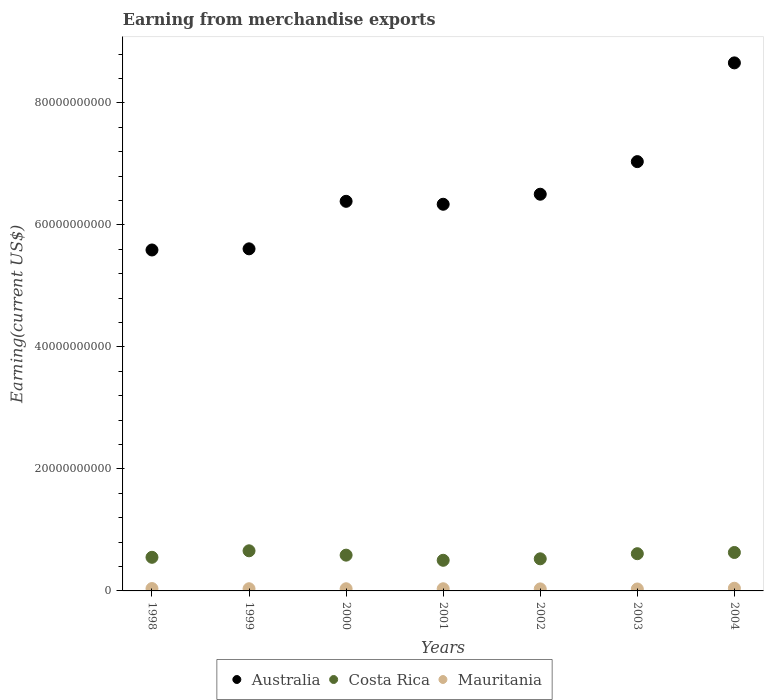How many different coloured dotlines are there?
Provide a succinct answer. 3. Is the number of dotlines equal to the number of legend labels?
Offer a terse response. Yes. What is the amount earned from merchandise exports in Mauritania in 1998?
Your response must be concise. 3.87e+08. Across all years, what is the maximum amount earned from merchandise exports in Australia?
Your answer should be very brief. 8.66e+1. Across all years, what is the minimum amount earned from merchandise exports in Mauritania?
Offer a very short reply. 3.18e+08. In which year was the amount earned from merchandise exports in Costa Rica maximum?
Keep it short and to the point. 1999. In which year was the amount earned from merchandise exports in Australia minimum?
Provide a short and direct response. 1998. What is the total amount earned from merchandise exports in Mauritania in the graph?
Offer a very short reply. 2.54e+09. What is the difference between the amount earned from merchandise exports in Costa Rica in 2000 and that in 2001?
Offer a very short reply. 8.44e+08. What is the difference between the amount earned from merchandise exports in Mauritania in 2002 and the amount earned from merchandise exports in Costa Rica in 1999?
Offer a very short reply. -6.25e+09. What is the average amount earned from merchandise exports in Costa Rica per year?
Your response must be concise. 5.81e+09. In the year 1998, what is the difference between the amount earned from merchandise exports in Australia and amount earned from merchandise exports in Costa Rica?
Give a very brief answer. 5.04e+1. What is the ratio of the amount earned from merchandise exports in Australia in 1998 to that in 2003?
Your response must be concise. 0.79. What is the difference between the highest and the second highest amount earned from merchandise exports in Australia?
Offer a terse response. 1.62e+1. What is the difference between the highest and the lowest amount earned from merchandise exports in Australia?
Your answer should be compact. 3.07e+1. In how many years, is the amount earned from merchandise exports in Mauritania greater than the average amount earned from merchandise exports in Mauritania taken over all years?
Provide a succinct answer. 2. Is it the case that in every year, the sum of the amount earned from merchandise exports in Australia and amount earned from merchandise exports in Mauritania  is greater than the amount earned from merchandise exports in Costa Rica?
Your answer should be compact. Yes. Does the amount earned from merchandise exports in Australia monotonically increase over the years?
Your answer should be very brief. No. Does the graph contain grids?
Keep it short and to the point. No. Where does the legend appear in the graph?
Your answer should be very brief. Bottom center. How many legend labels are there?
Keep it short and to the point. 3. What is the title of the graph?
Your answer should be compact. Earning from merchandise exports. Does "Antigua and Barbuda" appear as one of the legend labels in the graph?
Your answer should be very brief. No. What is the label or title of the X-axis?
Keep it short and to the point. Years. What is the label or title of the Y-axis?
Keep it short and to the point. Earning(current US$). What is the Earning(current US$) of Australia in 1998?
Offer a very short reply. 5.59e+1. What is the Earning(current US$) in Costa Rica in 1998?
Your answer should be very brief. 5.51e+09. What is the Earning(current US$) of Mauritania in 1998?
Your answer should be compact. 3.87e+08. What is the Earning(current US$) of Australia in 1999?
Provide a short and direct response. 5.61e+1. What is the Earning(current US$) of Costa Rica in 1999?
Give a very brief answer. 6.58e+09. What is the Earning(current US$) in Mauritania in 1999?
Make the answer very short. 3.58e+08. What is the Earning(current US$) of Australia in 2000?
Offer a terse response. 6.39e+1. What is the Earning(current US$) in Costa Rica in 2000?
Offer a terse response. 5.86e+09. What is the Earning(current US$) in Mauritania in 2000?
Give a very brief answer. 3.55e+08. What is the Earning(current US$) of Australia in 2001?
Make the answer very short. 6.34e+1. What is the Earning(current US$) in Costa Rica in 2001?
Your response must be concise. 5.02e+09. What is the Earning(current US$) in Mauritania in 2001?
Provide a short and direct response. 3.55e+08. What is the Earning(current US$) of Australia in 2002?
Your answer should be compact. 6.50e+1. What is the Earning(current US$) in Costa Rica in 2002?
Your answer should be compact. 5.26e+09. What is the Earning(current US$) of Mauritania in 2002?
Your answer should be compact. 3.32e+08. What is the Earning(current US$) in Australia in 2003?
Your answer should be very brief. 7.04e+1. What is the Earning(current US$) in Costa Rica in 2003?
Make the answer very short. 6.10e+09. What is the Earning(current US$) in Mauritania in 2003?
Ensure brevity in your answer.  3.18e+08. What is the Earning(current US$) in Australia in 2004?
Make the answer very short. 8.66e+1. What is the Earning(current US$) in Costa Rica in 2004?
Provide a short and direct response. 6.30e+09. What is the Earning(current US$) of Mauritania in 2004?
Make the answer very short. 4.40e+08. Across all years, what is the maximum Earning(current US$) in Australia?
Make the answer very short. 8.66e+1. Across all years, what is the maximum Earning(current US$) in Costa Rica?
Ensure brevity in your answer.  6.58e+09. Across all years, what is the maximum Earning(current US$) in Mauritania?
Give a very brief answer. 4.40e+08. Across all years, what is the minimum Earning(current US$) in Australia?
Keep it short and to the point. 5.59e+1. Across all years, what is the minimum Earning(current US$) of Costa Rica?
Your response must be concise. 5.02e+09. Across all years, what is the minimum Earning(current US$) of Mauritania?
Provide a short and direct response. 3.18e+08. What is the total Earning(current US$) in Australia in the graph?
Your answer should be very brief. 4.61e+11. What is the total Earning(current US$) of Costa Rica in the graph?
Your response must be concise. 4.06e+1. What is the total Earning(current US$) of Mauritania in the graph?
Give a very brief answer. 2.54e+09. What is the difference between the Earning(current US$) of Australia in 1998 and that in 1999?
Ensure brevity in your answer.  -1.87e+08. What is the difference between the Earning(current US$) in Costa Rica in 1998 and that in 1999?
Provide a succinct answer. -1.07e+09. What is the difference between the Earning(current US$) in Mauritania in 1998 and that in 1999?
Make the answer very short. 2.89e+07. What is the difference between the Earning(current US$) in Australia in 1998 and that in 2000?
Keep it short and to the point. -7.98e+09. What is the difference between the Earning(current US$) of Costa Rica in 1998 and that in 2000?
Ensure brevity in your answer.  -3.54e+08. What is the difference between the Earning(current US$) of Mauritania in 1998 and that in 2000?
Keep it short and to the point. 3.22e+07. What is the difference between the Earning(current US$) of Australia in 1998 and that in 2001?
Keep it short and to the point. -7.49e+09. What is the difference between the Earning(current US$) of Costa Rica in 1998 and that in 2001?
Ensure brevity in your answer.  4.90e+08. What is the difference between the Earning(current US$) of Mauritania in 1998 and that in 2001?
Ensure brevity in your answer.  3.15e+07. What is the difference between the Earning(current US$) in Australia in 1998 and that in 2002?
Ensure brevity in your answer.  -9.14e+09. What is the difference between the Earning(current US$) of Costa Rica in 1998 and that in 2002?
Your answer should be compact. 2.47e+08. What is the difference between the Earning(current US$) in Mauritania in 1998 and that in 2002?
Provide a short and direct response. 5.51e+07. What is the difference between the Earning(current US$) of Australia in 1998 and that in 2003?
Ensure brevity in your answer.  -1.45e+1. What is the difference between the Earning(current US$) in Costa Rica in 1998 and that in 2003?
Your answer should be compact. -5.91e+08. What is the difference between the Earning(current US$) of Mauritania in 1998 and that in 2003?
Provide a succinct answer. 6.84e+07. What is the difference between the Earning(current US$) in Australia in 1998 and that in 2004?
Make the answer very short. -3.07e+1. What is the difference between the Earning(current US$) of Costa Rica in 1998 and that in 2004?
Your answer should be very brief. -7.90e+08. What is the difference between the Earning(current US$) of Mauritania in 1998 and that in 2004?
Ensure brevity in your answer.  -5.29e+07. What is the difference between the Earning(current US$) of Australia in 1999 and that in 2000?
Make the answer very short. -7.79e+09. What is the difference between the Earning(current US$) of Costa Rica in 1999 and that in 2000?
Provide a succinct answer. 7.12e+08. What is the difference between the Earning(current US$) in Mauritania in 1999 and that in 2000?
Your answer should be very brief. 3.26e+06. What is the difference between the Earning(current US$) in Australia in 1999 and that in 2001?
Make the answer very short. -7.31e+09. What is the difference between the Earning(current US$) in Costa Rica in 1999 and that in 2001?
Your response must be concise. 1.56e+09. What is the difference between the Earning(current US$) of Mauritania in 1999 and that in 2001?
Provide a short and direct response. 2.58e+06. What is the difference between the Earning(current US$) in Australia in 1999 and that in 2002?
Provide a short and direct response. -8.95e+09. What is the difference between the Earning(current US$) of Costa Rica in 1999 and that in 2002?
Your answer should be compact. 1.31e+09. What is the difference between the Earning(current US$) of Mauritania in 1999 and that in 2002?
Your answer should be very brief. 2.62e+07. What is the difference between the Earning(current US$) in Australia in 1999 and that in 2003?
Offer a very short reply. -1.43e+1. What is the difference between the Earning(current US$) in Costa Rica in 1999 and that in 2003?
Offer a very short reply. 4.75e+08. What is the difference between the Earning(current US$) in Mauritania in 1999 and that in 2003?
Your answer should be very brief. 3.95e+07. What is the difference between the Earning(current US$) in Australia in 1999 and that in 2004?
Give a very brief answer. -3.05e+1. What is the difference between the Earning(current US$) in Costa Rica in 1999 and that in 2004?
Offer a very short reply. 2.76e+08. What is the difference between the Earning(current US$) in Mauritania in 1999 and that in 2004?
Provide a short and direct response. -8.18e+07. What is the difference between the Earning(current US$) of Australia in 2000 and that in 2001?
Your response must be concise. 4.83e+08. What is the difference between the Earning(current US$) in Costa Rica in 2000 and that in 2001?
Offer a terse response. 8.44e+08. What is the difference between the Earning(current US$) in Mauritania in 2000 and that in 2001?
Keep it short and to the point. -6.79e+05. What is the difference between the Earning(current US$) in Australia in 2000 and that in 2002?
Provide a short and direct response. -1.16e+09. What is the difference between the Earning(current US$) in Costa Rica in 2000 and that in 2002?
Make the answer very short. 6.01e+08. What is the difference between the Earning(current US$) in Mauritania in 2000 and that in 2002?
Keep it short and to the point. 2.29e+07. What is the difference between the Earning(current US$) of Australia in 2000 and that in 2003?
Your response must be concise. -6.51e+09. What is the difference between the Earning(current US$) in Costa Rica in 2000 and that in 2003?
Offer a terse response. -2.37e+08. What is the difference between the Earning(current US$) in Mauritania in 2000 and that in 2003?
Your answer should be compact. 3.62e+07. What is the difference between the Earning(current US$) in Australia in 2000 and that in 2004?
Make the answer very short. -2.27e+1. What is the difference between the Earning(current US$) in Costa Rica in 2000 and that in 2004?
Provide a succinct answer. -4.36e+08. What is the difference between the Earning(current US$) of Mauritania in 2000 and that in 2004?
Give a very brief answer. -8.50e+07. What is the difference between the Earning(current US$) of Australia in 2001 and that in 2002?
Make the answer very short. -1.65e+09. What is the difference between the Earning(current US$) in Costa Rica in 2001 and that in 2002?
Your answer should be very brief. -2.43e+08. What is the difference between the Earning(current US$) of Mauritania in 2001 and that in 2002?
Your answer should be very brief. 2.36e+07. What is the difference between the Earning(current US$) of Australia in 2001 and that in 2003?
Keep it short and to the point. -6.99e+09. What is the difference between the Earning(current US$) of Costa Rica in 2001 and that in 2003?
Offer a very short reply. -1.08e+09. What is the difference between the Earning(current US$) of Mauritania in 2001 and that in 2003?
Provide a short and direct response. 3.69e+07. What is the difference between the Earning(current US$) in Australia in 2001 and that in 2004?
Your response must be concise. -2.32e+1. What is the difference between the Earning(current US$) of Costa Rica in 2001 and that in 2004?
Offer a very short reply. -1.28e+09. What is the difference between the Earning(current US$) of Mauritania in 2001 and that in 2004?
Offer a very short reply. -8.44e+07. What is the difference between the Earning(current US$) of Australia in 2002 and that in 2003?
Offer a very short reply. -5.34e+09. What is the difference between the Earning(current US$) of Costa Rica in 2002 and that in 2003?
Make the answer very short. -8.38e+08. What is the difference between the Earning(current US$) in Mauritania in 2002 and that in 2003?
Ensure brevity in your answer.  1.33e+07. What is the difference between the Earning(current US$) of Australia in 2002 and that in 2004?
Offer a very short reply. -2.15e+1. What is the difference between the Earning(current US$) of Costa Rica in 2002 and that in 2004?
Provide a succinct answer. -1.04e+09. What is the difference between the Earning(current US$) of Mauritania in 2002 and that in 2004?
Provide a succinct answer. -1.08e+08. What is the difference between the Earning(current US$) in Australia in 2003 and that in 2004?
Keep it short and to the point. -1.62e+1. What is the difference between the Earning(current US$) of Costa Rica in 2003 and that in 2004?
Make the answer very short. -1.99e+08. What is the difference between the Earning(current US$) of Mauritania in 2003 and that in 2004?
Your answer should be compact. -1.21e+08. What is the difference between the Earning(current US$) of Australia in 1998 and the Earning(current US$) of Costa Rica in 1999?
Offer a terse response. 4.93e+1. What is the difference between the Earning(current US$) in Australia in 1998 and the Earning(current US$) in Mauritania in 1999?
Provide a succinct answer. 5.55e+1. What is the difference between the Earning(current US$) in Costa Rica in 1998 and the Earning(current US$) in Mauritania in 1999?
Provide a succinct answer. 5.15e+09. What is the difference between the Earning(current US$) of Australia in 1998 and the Earning(current US$) of Costa Rica in 2000?
Your answer should be very brief. 5.00e+1. What is the difference between the Earning(current US$) of Australia in 1998 and the Earning(current US$) of Mauritania in 2000?
Provide a short and direct response. 5.55e+1. What is the difference between the Earning(current US$) in Costa Rica in 1998 and the Earning(current US$) in Mauritania in 2000?
Give a very brief answer. 5.16e+09. What is the difference between the Earning(current US$) in Australia in 1998 and the Earning(current US$) in Costa Rica in 2001?
Make the answer very short. 5.09e+1. What is the difference between the Earning(current US$) of Australia in 1998 and the Earning(current US$) of Mauritania in 2001?
Make the answer very short. 5.55e+1. What is the difference between the Earning(current US$) of Costa Rica in 1998 and the Earning(current US$) of Mauritania in 2001?
Offer a terse response. 5.16e+09. What is the difference between the Earning(current US$) of Australia in 1998 and the Earning(current US$) of Costa Rica in 2002?
Give a very brief answer. 5.06e+1. What is the difference between the Earning(current US$) in Australia in 1998 and the Earning(current US$) in Mauritania in 2002?
Provide a short and direct response. 5.56e+1. What is the difference between the Earning(current US$) in Costa Rica in 1998 and the Earning(current US$) in Mauritania in 2002?
Ensure brevity in your answer.  5.18e+09. What is the difference between the Earning(current US$) in Australia in 1998 and the Earning(current US$) in Costa Rica in 2003?
Your response must be concise. 4.98e+1. What is the difference between the Earning(current US$) of Australia in 1998 and the Earning(current US$) of Mauritania in 2003?
Your answer should be very brief. 5.56e+1. What is the difference between the Earning(current US$) in Costa Rica in 1998 and the Earning(current US$) in Mauritania in 2003?
Ensure brevity in your answer.  5.19e+09. What is the difference between the Earning(current US$) of Australia in 1998 and the Earning(current US$) of Costa Rica in 2004?
Your answer should be compact. 4.96e+1. What is the difference between the Earning(current US$) in Australia in 1998 and the Earning(current US$) in Mauritania in 2004?
Your answer should be very brief. 5.55e+1. What is the difference between the Earning(current US$) of Costa Rica in 1998 and the Earning(current US$) of Mauritania in 2004?
Offer a terse response. 5.07e+09. What is the difference between the Earning(current US$) of Australia in 1999 and the Earning(current US$) of Costa Rica in 2000?
Keep it short and to the point. 5.02e+1. What is the difference between the Earning(current US$) of Australia in 1999 and the Earning(current US$) of Mauritania in 2000?
Provide a succinct answer. 5.57e+1. What is the difference between the Earning(current US$) in Costa Rica in 1999 and the Earning(current US$) in Mauritania in 2000?
Your answer should be very brief. 6.22e+09. What is the difference between the Earning(current US$) in Australia in 1999 and the Earning(current US$) in Costa Rica in 2001?
Your answer should be compact. 5.11e+1. What is the difference between the Earning(current US$) in Australia in 1999 and the Earning(current US$) in Mauritania in 2001?
Keep it short and to the point. 5.57e+1. What is the difference between the Earning(current US$) of Costa Rica in 1999 and the Earning(current US$) of Mauritania in 2001?
Provide a short and direct response. 6.22e+09. What is the difference between the Earning(current US$) of Australia in 1999 and the Earning(current US$) of Costa Rica in 2002?
Offer a terse response. 5.08e+1. What is the difference between the Earning(current US$) of Australia in 1999 and the Earning(current US$) of Mauritania in 2002?
Give a very brief answer. 5.57e+1. What is the difference between the Earning(current US$) of Costa Rica in 1999 and the Earning(current US$) of Mauritania in 2002?
Keep it short and to the point. 6.25e+09. What is the difference between the Earning(current US$) of Australia in 1999 and the Earning(current US$) of Costa Rica in 2003?
Your response must be concise. 5.00e+1. What is the difference between the Earning(current US$) in Australia in 1999 and the Earning(current US$) in Mauritania in 2003?
Your response must be concise. 5.58e+1. What is the difference between the Earning(current US$) in Costa Rica in 1999 and the Earning(current US$) in Mauritania in 2003?
Offer a terse response. 6.26e+09. What is the difference between the Earning(current US$) of Australia in 1999 and the Earning(current US$) of Costa Rica in 2004?
Provide a short and direct response. 4.98e+1. What is the difference between the Earning(current US$) of Australia in 1999 and the Earning(current US$) of Mauritania in 2004?
Offer a very short reply. 5.56e+1. What is the difference between the Earning(current US$) of Costa Rica in 1999 and the Earning(current US$) of Mauritania in 2004?
Provide a succinct answer. 6.14e+09. What is the difference between the Earning(current US$) of Australia in 2000 and the Earning(current US$) of Costa Rica in 2001?
Offer a very short reply. 5.88e+1. What is the difference between the Earning(current US$) in Australia in 2000 and the Earning(current US$) in Mauritania in 2001?
Keep it short and to the point. 6.35e+1. What is the difference between the Earning(current US$) in Costa Rica in 2000 and the Earning(current US$) in Mauritania in 2001?
Your response must be concise. 5.51e+09. What is the difference between the Earning(current US$) of Australia in 2000 and the Earning(current US$) of Costa Rica in 2002?
Your answer should be compact. 5.86e+1. What is the difference between the Earning(current US$) in Australia in 2000 and the Earning(current US$) in Mauritania in 2002?
Give a very brief answer. 6.35e+1. What is the difference between the Earning(current US$) in Costa Rica in 2000 and the Earning(current US$) in Mauritania in 2002?
Provide a succinct answer. 5.53e+09. What is the difference between the Earning(current US$) of Australia in 2000 and the Earning(current US$) of Costa Rica in 2003?
Your answer should be very brief. 5.78e+1. What is the difference between the Earning(current US$) of Australia in 2000 and the Earning(current US$) of Mauritania in 2003?
Make the answer very short. 6.36e+1. What is the difference between the Earning(current US$) of Costa Rica in 2000 and the Earning(current US$) of Mauritania in 2003?
Your answer should be compact. 5.55e+09. What is the difference between the Earning(current US$) of Australia in 2000 and the Earning(current US$) of Costa Rica in 2004?
Your answer should be compact. 5.76e+1. What is the difference between the Earning(current US$) in Australia in 2000 and the Earning(current US$) in Mauritania in 2004?
Keep it short and to the point. 6.34e+1. What is the difference between the Earning(current US$) in Costa Rica in 2000 and the Earning(current US$) in Mauritania in 2004?
Ensure brevity in your answer.  5.43e+09. What is the difference between the Earning(current US$) of Australia in 2001 and the Earning(current US$) of Costa Rica in 2002?
Offer a very short reply. 5.81e+1. What is the difference between the Earning(current US$) of Australia in 2001 and the Earning(current US$) of Mauritania in 2002?
Your response must be concise. 6.31e+1. What is the difference between the Earning(current US$) in Costa Rica in 2001 and the Earning(current US$) in Mauritania in 2002?
Your answer should be compact. 4.69e+09. What is the difference between the Earning(current US$) in Australia in 2001 and the Earning(current US$) in Costa Rica in 2003?
Offer a very short reply. 5.73e+1. What is the difference between the Earning(current US$) of Australia in 2001 and the Earning(current US$) of Mauritania in 2003?
Ensure brevity in your answer.  6.31e+1. What is the difference between the Earning(current US$) of Costa Rica in 2001 and the Earning(current US$) of Mauritania in 2003?
Offer a very short reply. 4.70e+09. What is the difference between the Earning(current US$) in Australia in 2001 and the Earning(current US$) in Costa Rica in 2004?
Your response must be concise. 5.71e+1. What is the difference between the Earning(current US$) of Australia in 2001 and the Earning(current US$) of Mauritania in 2004?
Keep it short and to the point. 6.29e+1. What is the difference between the Earning(current US$) of Costa Rica in 2001 and the Earning(current US$) of Mauritania in 2004?
Provide a succinct answer. 4.58e+09. What is the difference between the Earning(current US$) of Australia in 2002 and the Earning(current US$) of Costa Rica in 2003?
Your response must be concise. 5.89e+1. What is the difference between the Earning(current US$) of Australia in 2002 and the Earning(current US$) of Mauritania in 2003?
Your response must be concise. 6.47e+1. What is the difference between the Earning(current US$) of Costa Rica in 2002 and the Earning(current US$) of Mauritania in 2003?
Your answer should be very brief. 4.95e+09. What is the difference between the Earning(current US$) in Australia in 2002 and the Earning(current US$) in Costa Rica in 2004?
Your answer should be very brief. 5.87e+1. What is the difference between the Earning(current US$) of Australia in 2002 and the Earning(current US$) of Mauritania in 2004?
Give a very brief answer. 6.46e+1. What is the difference between the Earning(current US$) in Costa Rica in 2002 and the Earning(current US$) in Mauritania in 2004?
Your answer should be very brief. 4.82e+09. What is the difference between the Earning(current US$) in Australia in 2003 and the Earning(current US$) in Costa Rica in 2004?
Make the answer very short. 6.41e+1. What is the difference between the Earning(current US$) of Australia in 2003 and the Earning(current US$) of Mauritania in 2004?
Provide a short and direct response. 6.99e+1. What is the difference between the Earning(current US$) of Costa Rica in 2003 and the Earning(current US$) of Mauritania in 2004?
Your answer should be very brief. 5.66e+09. What is the average Earning(current US$) in Australia per year?
Offer a very short reply. 6.59e+1. What is the average Earning(current US$) of Costa Rica per year?
Provide a short and direct response. 5.81e+09. What is the average Earning(current US$) of Mauritania per year?
Your answer should be very brief. 3.63e+08. In the year 1998, what is the difference between the Earning(current US$) in Australia and Earning(current US$) in Costa Rica?
Keep it short and to the point. 5.04e+1. In the year 1998, what is the difference between the Earning(current US$) of Australia and Earning(current US$) of Mauritania?
Provide a short and direct response. 5.55e+1. In the year 1998, what is the difference between the Earning(current US$) of Costa Rica and Earning(current US$) of Mauritania?
Provide a short and direct response. 5.12e+09. In the year 1999, what is the difference between the Earning(current US$) in Australia and Earning(current US$) in Costa Rica?
Offer a terse response. 4.95e+1. In the year 1999, what is the difference between the Earning(current US$) in Australia and Earning(current US$) in Mauritania?
Your answer should be compact. 5.57e+1. In the year 1999, what is the difference between the Earning(current US$) of Costa Rica and Earning(current US$) of Mauritania?
Your answer should be very brief. 6.22e+09. In the year 2000, what is the difference between the Earning(current US$) in Australia and Earning(current US$) in Costa Rica?
Ensure brevity in your answer.  5.80e+1. In the year 2000, what is the difference between the Earning(current US$) of Australia and Earning(current US$) of Mauritania?
Keep it short and to the point. 6.35e+1. In the year 2000, what is the difference between the Earning(current US$) in Costa Rica and Earning(current US$) in Mauritania?
Your response must be concise. 5.51e+09. In the year 2001, what is the difference between the Earning(current US$) in Australia and Earning(current US$) in Costa Rica?
Your response must be concise. 5.84e+1. In the year 2001, what is the difference between the Earning(current US$) in Australia and Earning(current US$) in Mauritania?
Make the answer very short. 6.30e+1. In the year 2001, what is the difference between the Earning(current US$) in Costa Rica and Earning(current US$) in Mauritania?
Ensure brevity in your answer.  4.67e+09. In the year 2002, what is the difference between the Earning(current US$) in Australia and Earning(current US$) in Costa Rica?
Your answer should be very brief. 5.98e+1. In the year 2002, what is the difference between the Earning(current US$) of Australia and Earning(current US$) of Mauritania?
Offer a very short reply. 6.47e+1. In the year 2002, what is the difference between the Earning(current US$) of Costa Rica and Earning(current US$) of Mauritania?
Your answer should be very brief. 4.93e+09. In the year 2003, what is the difference between the Earning(current US$) in Australia and Earning(current US$) in Costa Rica?
Your response must be concise. 6.43e+1. In the year 2003, what is the difference between the Earning(current US$) of Australia and Earning(current US$) of Mauritania?
Your answer should be very brief. 7.01e+1. In the year 2003, what is the difference between the Earning(current US$) in Costa Rica and Earning(current US$) in Mauritania?
Provide a succinct answer. 5.78e+09. In the year 2004, what is the difference between the Earning(current US$) in Australia and Earning(current US$) in Costa Rica?
Your answer should be compact. 8.03e+1. In the year 2004, what is the difference between the Earning(current US$) of Australia and Earning(current US$) of Mauritania?
Your answer should be very brief. 8.61e+1. In the year 2004, what is the difference between the Earning(current US$) in Costa Rica and Earning(current US$) in Mauritania?
Your answer should be compact. 5.86e+09. What is the ratio of the Earning(current US$) in Costa Rica in 1998 to that in 1999?
Give a very brief answer. 0.84. What is the ratio of the Earning(current US$) in Mauritania in 1998 to that in 1999?
Provide a short and direct response. 1.08. What is the ratio of the Earning(current US$) in Australia in 1998 to that in 2000?
Offer a terse response. 0.88. What is the ratio of the Earning(current US$) in Costa Rica in 1998 to that in 2000?
Your response must be concise. 0.94. What is the ratio of the Earning(current US$) in Mauritania in 1998 to that in 2000?
Provide a succinct answer. 1.09. What is the ratio of the Earning(current US$) in Australia in 1998 to that in 2001?
Your answer should be very brief. 0.88. What is the ratio of the Earning(current US$) in Costa Rica in 1998 to that in 2001?
Your answer should be compact. 1.1. What is the ratio of the Earning(current US$) in Mauritania in 1998 to that in 2001?
Keep it short and to the point. 1.09. What is the ratio of the Earning(current US$) of Australia in 1998 to that in 2002?
Provide a short and direct response. 0.86. What is the ratio of the Earning(current US$) in Costa Rica in 1998 to that in 2002?
Keep it short and to the point. 1.05. What is the ratio of the Earning(current US$) of Mauritania in 1998 to that in 2002?
Ensure brevity in your answer.  1.17. What is the ratio of the Earning(current US$) in Australia in 1998 to that in 2003?
Make the answer very short. 0.79. What is the ratio of the Earning(current US$) in Costa Rica in 1998 to that in 2003?
Ensure brevity in your answer.  0.9. What is the ratio of the Earning(current US$) in Mauritania in 1998 to that in 2003?
Give a very brief answer. 1.21. What is the ratio of the Earning(current US$) in Australia in 1998 to that in 2004?
Offer a terse response. 0.65. What is the ratio of the Earning(current US$) in Costa Rica in 1998 to that in 2004?
Your answer should be very brief. 0.87. What is the ratio of the Earning(current US$) of Mauritania in 1998 to that in 2004?
Ensure brevity in your answer.  0.88. What is the ratio of the Earning(current US$) in Australia in 1999 to that in 2000?
Keep it short and to the point. 0.88. What is the ratio of the Earning(current US$) of Costa Rica in 1999 to that in 2000?
Keep it short and to the point. 1.12. What is the ratio of the Earning(current US$) of Mauritania in 1999 to that in 2000?
Provide a short and direct response. 1.01. What is the ratio of the Earning(current US$) of Australia in 1999 to that in 2001?
Provide a succinct answer. 0.88. What is the ratio of the Earning(current US$) in Costa Rica in 1999 to that in 2001?
Ensure brevity in your answer.  1.31. What is the ratio of the Earning(current US$) in Mauritania in 1999 to that in 2001?
Offer a very short reply. 1.01. What is the ratio of the Earning(current US$) in Australia in 1999 to that in 2002?
Your answer should be compact. 0.86. What is the ratio of the Earning(current US$) of Costa Rica in 1999 to that in 2002?
Provide a short and direct response. 1.25. What is the ratio of the Earning(current US$) in Mauritania in 1999 to that in 2002?
Provide a succinct answer. 1.08. What is the ratio of the Earning(current US$) of Australia in 1999 to that in 2003?
Ensure brevity in your answer.  0.8. What is the ratio of the Earning(current US$) in Costa Rica in 1999 to that in 2003?
Your response must be concise. 1.08. What is the ratio of the Earning(current US$) in Mauritania in 1999 to that in 2003?
Keep it short and to the point. 1.12. What is the ratio of the Earning(current US$) in Australia in 1999 to that in 2004?
Provide a succinct answer. 0.65. What is the ratio of the Earning(current US$) in Costa Rica in 1999 to that in 2004?
Your response must be concise. 1.04. What is the ratio of the Earning(current US$) in Mauritania in 1999 to that in 2004?
Offer a terse response. 0.81. What is the ratio of the Earning(current US$) of Australia in 2000 to that in 2001?
Your response must be concise. 1.01. What is the ratio of the Earning(current US$) of Costa Rica in 2000 to that in 2001?
Your answer should be compact. 1.17. What is the ratio of the Earning(current US$) in Mauritania in 2000 to that in 2001?
Give a very brief answer. 1. What is the ratio of the Earning(current US$) of Australia in 2000 to that in 2002?
Your response must be concise. 0.98. What is the ratio of the Earning(current US$) in Costa Rica in 2000 to that in 2002?
Make the answer very short. 1.11. What is the ratio of the Earning(current US$) in Mauritania in 2000 to that in 2002?
Your response must be concise. 1.07. What is the ratio of the Earning(current US$) of Australia in 2000 to that in 2003?
Keep it short and to the point. 0.91. What is the ratio of the Earning(current US$) in Costa Rica in 2000 to that in 2003?
Make the answer very short. 0.96. What is the ratio of the Earning(current US$) in Mauritania in 2000 to that in 2003?
Your response must be concise. 1.11. What is the ratio of the Earning(current US$) in Australia in 2000 to that in 2004?
Provide a succinct answer. 0.74. What is the ratio of the Earning(current US$) of Costa Rica in 2000 to that in 2004?
Ensure brevity in your answer.  0.93. What is the ratio of the Earning(current US$) of Mauritania in 2000 to that in 2004?
Your response must be concise. 0.81. What is the ratio of the Earning(current US$) in Australia in 2001 to that in 2002?
Your response must be concise. 0.97. What is the ratio of the Earning(current US$) in Costa Rica in 2001 to that in 2002?
Provide a short and direct response. 0.95. What is the ratio of the Earning(current US$) in Mauritania in 2001 to that in 2002?
Provide a succinct answer. 1.07. What is the ratio of the Earning(current US$) in Australia in 2001 to that in 2003?
Make the answer very short. 0.9. What is the ratio of the Earning(current US$) in Costa Rica in 2001 to that in 2003?
Ensure brevity in your answer.  0.82. What is the ratio of the Earning(current US$) in Mauritania in 2001 to that in 2003?
Offer a very short reply. 1.12. What is the ratio of the Earning(current US$) in Australia in 2001 to that in 2004?
Offer a terse response. 0.73. What is the ratio of the Earning(current US$) of Costa Rica in 2001 to that in 2004?
Give a very brief answer. 0.8. What is the ratio of the Earning(current US$) in Mauritania in 2001 to that in 2004?
Keep it short and to the point. 0.81. What is the ratio of the Earning(current US$) of Australia in 2002 to that in 2003?
Your answer should be very brief. 0.92. What is the ratio of the Earning(current US$) in Costa Rica in 2002 to that in 2003?
Offer a terse response. 0.86. What is the ratio of the Earning(current US$) of Mauritania in 2002 to that in 2003?
Keep it short and to the point. 1.04. What is the ratio of the Earning(current US$) in Australia in 2002 to that in 2004?
Your answer should be very brief. 0.75. What is the ratio of the Earning(current US$) in Costa Rica in 2002 to that in 2004?
Give a very brief answer. 0.84. What is the ratio of the Earning(current US$) of Mauritania in 2002 to that in 2004?
Keep it short and to the point. 0.75. What is the ratio of the Earning(current US$) in Australia in 2003 to that in 2004?
Provide a short and direct response. 0.81. What is the ratio of the Earning(current US$) of Costa Rica in 2003 to that in 2004?
Your answer should be very brief. 0.97. What is the ratio of the Earning(current US$) of Mauritania in 2003 to that in 2004?
Offer a terse response. 0.72. What is the difference between the highest and the second highest Earning(current US$) of Australia?
Your answer should be very brief. 1.62e+1. What is the difference between the highest and the second highest Earning(current US$) in Costa Rica?
Keep it short and to the point. 2.76e+08. What is the difference between the highest and the second highest Earning(current US$) of Mauritania?
Offer a terse response. 5.29e+07. What is the difference between the highest and the lowest Earning(current US$) in Australia?
Give a very brief answer. 3.07e+1. What is the difference between the highest and the lowest Earning(current US$) in Costa Rica?
Your answer should be compact. 1.56e+09. What is the difference between the highest and the lowest Earning(current US$) of Mauritania?
Provide a short and direct response. 1.21e+08. 